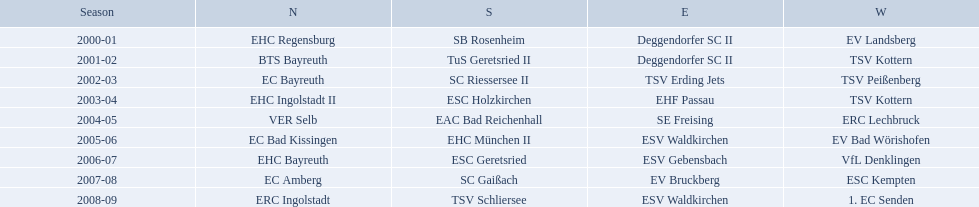Parse the table in full. {'header': ['Season', 'N', 'S', 'E', 'W'], 'rows': [['2000-01', 'EHC Regensburg', 'SB Rosenheim', 'Deggendorfer SC II', 'EV Landsberg'], ['2001-02', 'BTS Bayreuth', 'TuS Geretsried II', 'Deggendorfer SC II', 'TSV Kottern'], ['2002-03', 'EC Bayreuth', 'SC Riessersee II', 'TSV Erding Jets', 'TSV Peißenberg'], ['2003-04', 'EHC Ingolstadt II', 'ESC Holzkirchen', 'EHF Passau', 'TSV Kottern'], ['2004-05', 'VER Selb', 'EAC Bad Reichenhall', 'SE Freising', 'ERC Lechbruck'], ['2005-06', 'EC Bad Kissingen', 'EHC München II', 'ESV Waldkirchen', 'EV Bad Wörishofen'], ['2006-07', 'EHC Bayreuth', 'ESC Geretsried', 'ESV Gebensbach', 'VfL Denklingen'], ['2007-08', 'EC Amberg', 'SC Gaißach', 'EV Bruckberg', 'ESC Kempten'], ['2008-09', 'ERC Ingolstadt', 'TSV Schliersee', 'ESV Waldkirchen', '1. EC Senden']]} Which teams won the north in their respective years? 2000-01, EHC Regensburg, BTS Bayreuth, EC Bayreuth, EHC Ingolstadt II, VER Selb, EC Bad Kissingen, EHC Bayreuth, EC Amberg, ERC Ingolstadt. Which one only won in 2000-01? EHC Regensburg. Which teams played in the north? EHC Regensburg, BTS Bayreuth, EC Bayreuth, EHC Ingolstadt II, VER Selb, EC Bad Kissingen, EHC Bayreuth, EC Amberg, ERC Ingolstadt. Of these teams, which played during 2000-2001? EHC Regensburg. Parse the full table. {'header': ['Season', 'N', 'S', 'E', 'W'], 'rows': [['2000-01', 'EHC Regensburg', 'SB Rosenheim', 'Deggendorfer SC II', 'EV Landsberg'], ['2001-02', 'BTS Bayreuth', 'TuS Geretsried II', 'Deggendorfer SC II', 'TSV Kottern'], ['2002-03', 'EC Bayreuth', 'SC Riessersee II', 'TSV Erding Jets', 'TSV Peißenberg'], ['2003-04', 'EHC Ingolstadt II', 'ESC Holzkirchen', 'EHF Passau', 'TSV Kottern'], ['2004-05', 'VER Selb', 'EAC Bad Reichenhall', 'SE Freising', 'ERC Lechbruck'], ['2005-06', 'EC Bad Kissingen', 'EHC München II', 'ESV Waldkirchen', 'EV Bad Wörishofen'], ['2006-07', 'EHC Bayreuth', 'ESC Geretsried', 'ESV Gebensbach', 'VfL Denklingen'], ['2007-08', 'EC Amberg', 'SC Gaißach', 'EV Bruckberg', 'ESC Kempten'], ['2008-09', 'ERC Ingolstadt', 'TSV Schliersee', 'ESV Waldkirchen', '1. EC Senden']]} 